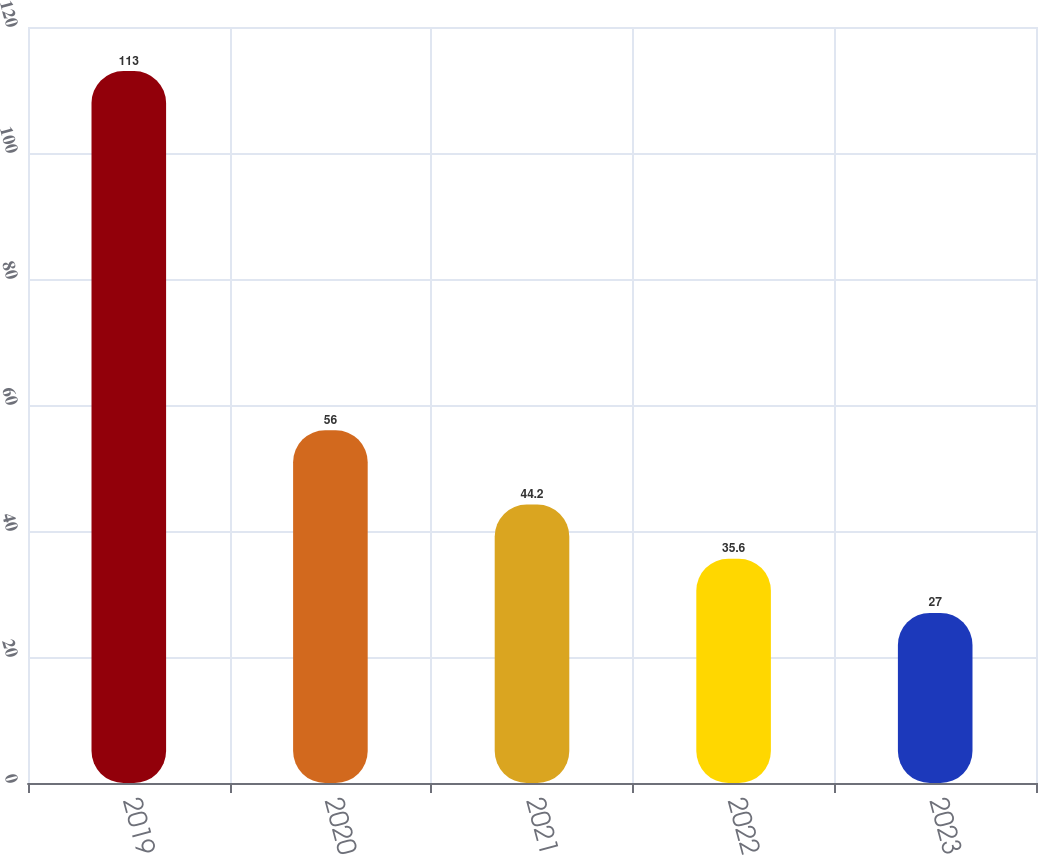<chart> <loc_0><loc_0><loc_500><loc_500><bar_chart><fcel>2019<fcel>2020<fcel>2021<fcel>2022<fcel>2023<nl><fcel>113<fcel>56<fcel>44.2<fcel>35.6<fcel>27<nl></chart> 